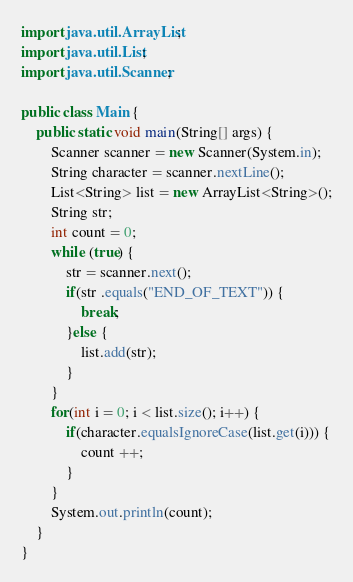<code> <loc_0><loc_0><loc_500><loc_500><_Java_>import java.util.ArrayList;
import java.util.List;
import java.util.Scanner;

public class Main {
	public static void main(String[] args) {
		Scanner scanner = new Scanner(System.in);
		String character = scanner.nextLine();
		List<String> list = new ArrayList<String>();
		String str;
		int count = 0;
		while (true) {
			str = scanner.next();			
			if(str .equals("END_OF_TEXT")) {
				break;
			}else {
				list.add(str);				
			}
		}
		for(int i = 0; i < list.size(); i++) {
			if(character.equalsIgnoreCase(list.get(i))) {
				count ++;
			}
		}
		System.out.println(count);
	}
}</code> 